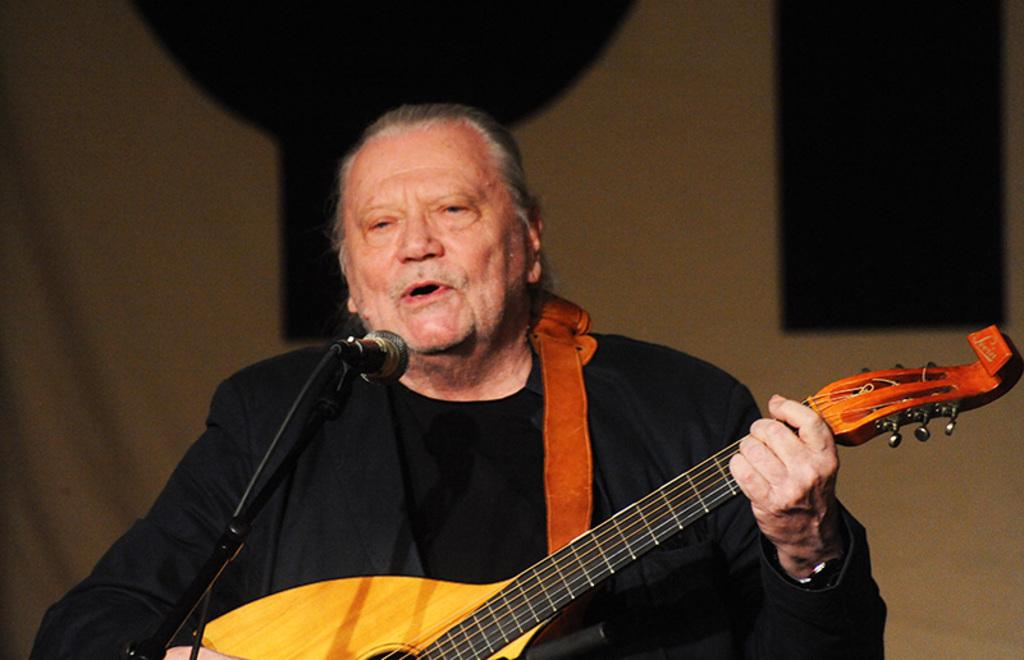What is the man in the image wearing? The man is wearing a guitar. What is the man holding in his hand? The man is holding a guitar in his hand. What device is present for amplifying sound in the image? There is a microphone in the image. How is the microphone positioned in the image? The microphone is on a stand. What can be seen in the background of the image? There is a cloth visible in the background of the image. How many chairs are visible in the image? There are no chairs visible in the image. What type of pickle is being used as a prop in the image? There is no pickle present in the image. 